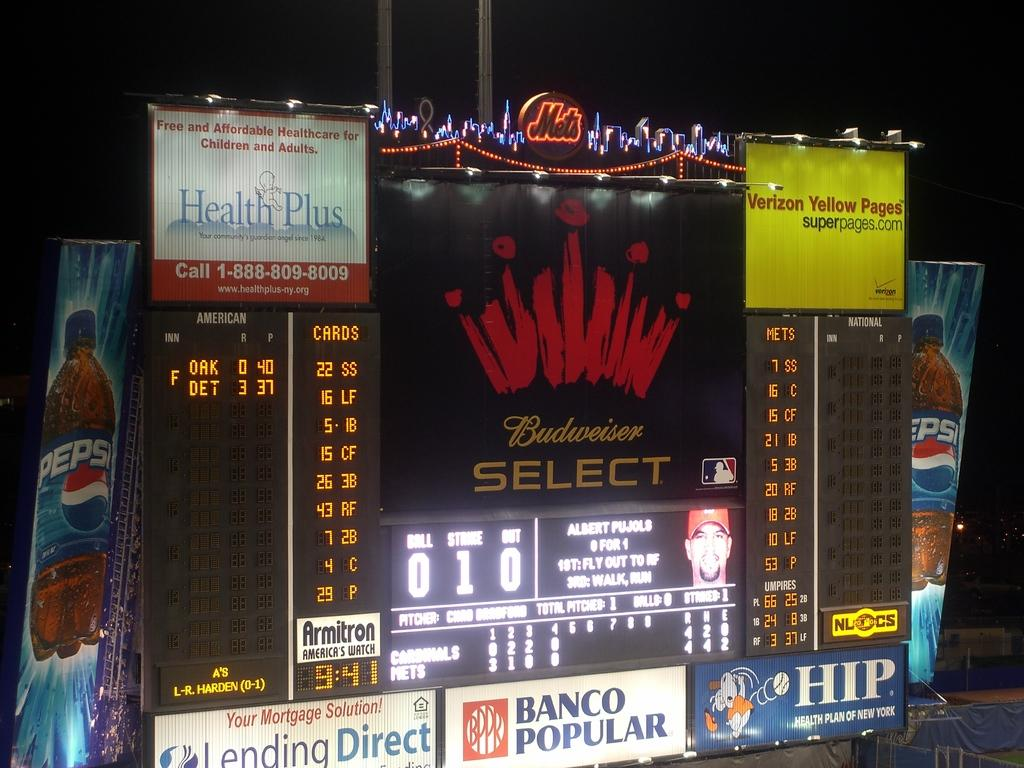<image>
Summarize the visual content of the image. A scoreboard with a Budweiser Select sign above it. 